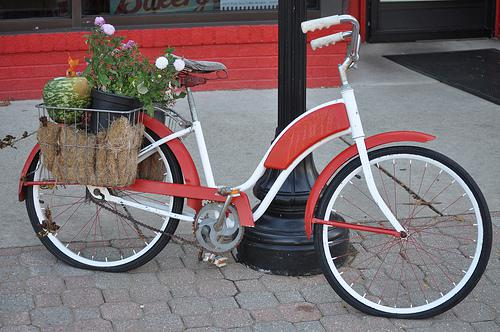Question: when was this picture taken?
Choices:
A. Night time.
B. Midnight.
C. Daytime.
D. Early morning.
Answer with the letter. Answer: C Question: where do you see a flower?
Choices:
A. On the ground.
B. In the bike basket.
C. In the air.
D. On the tree.
Answer with the letter. Answer: B Question: where do you see a chain?
Choices:
A. On the car.
B. On the bike.
C. On the house.
D. On the tree.
Answer with the letter. Answer: B Question: what color is the bike?
Choices:
A. Black and blue.
B. Red and white.
C. Green and yellow.
D. Tan and gold.
Answer with the letter. Answer: B Question: who is riding the bike?
Choices:
A. The man.
B. No one.
C. The woman.
D. The girl.
Answer with the letter. Answer: B 